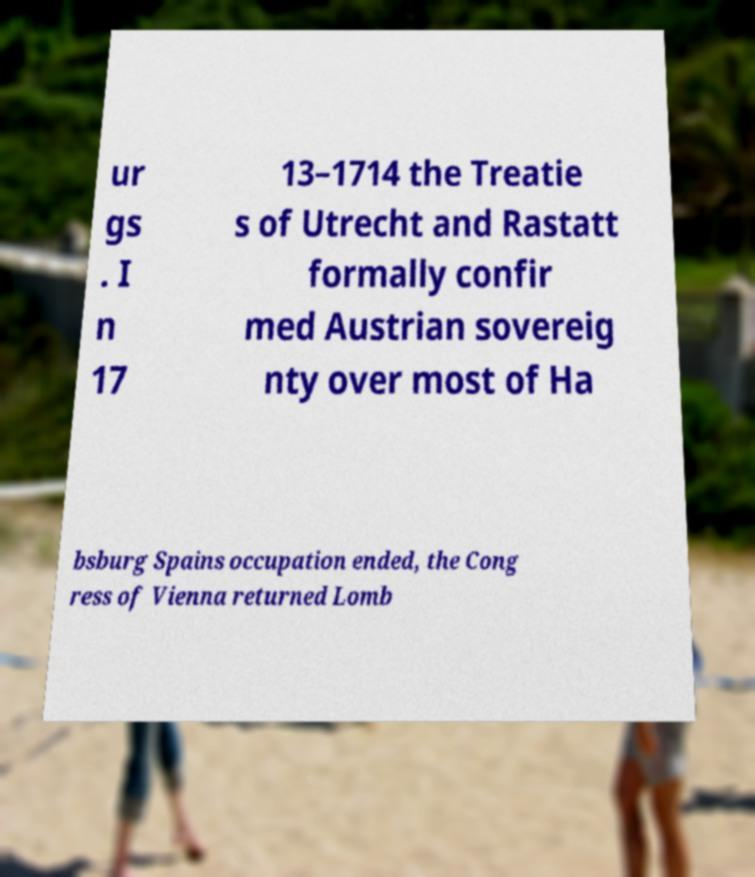Could you extract and type out the text from this image? ur gs . I n 17 13–1714 the Treatie s of Utrecht and Rastatt formally confir med Austrian sovereig nty over most of Ha bsburg Spains occupation ended, the Cong ress of Vienna returned Lomb 